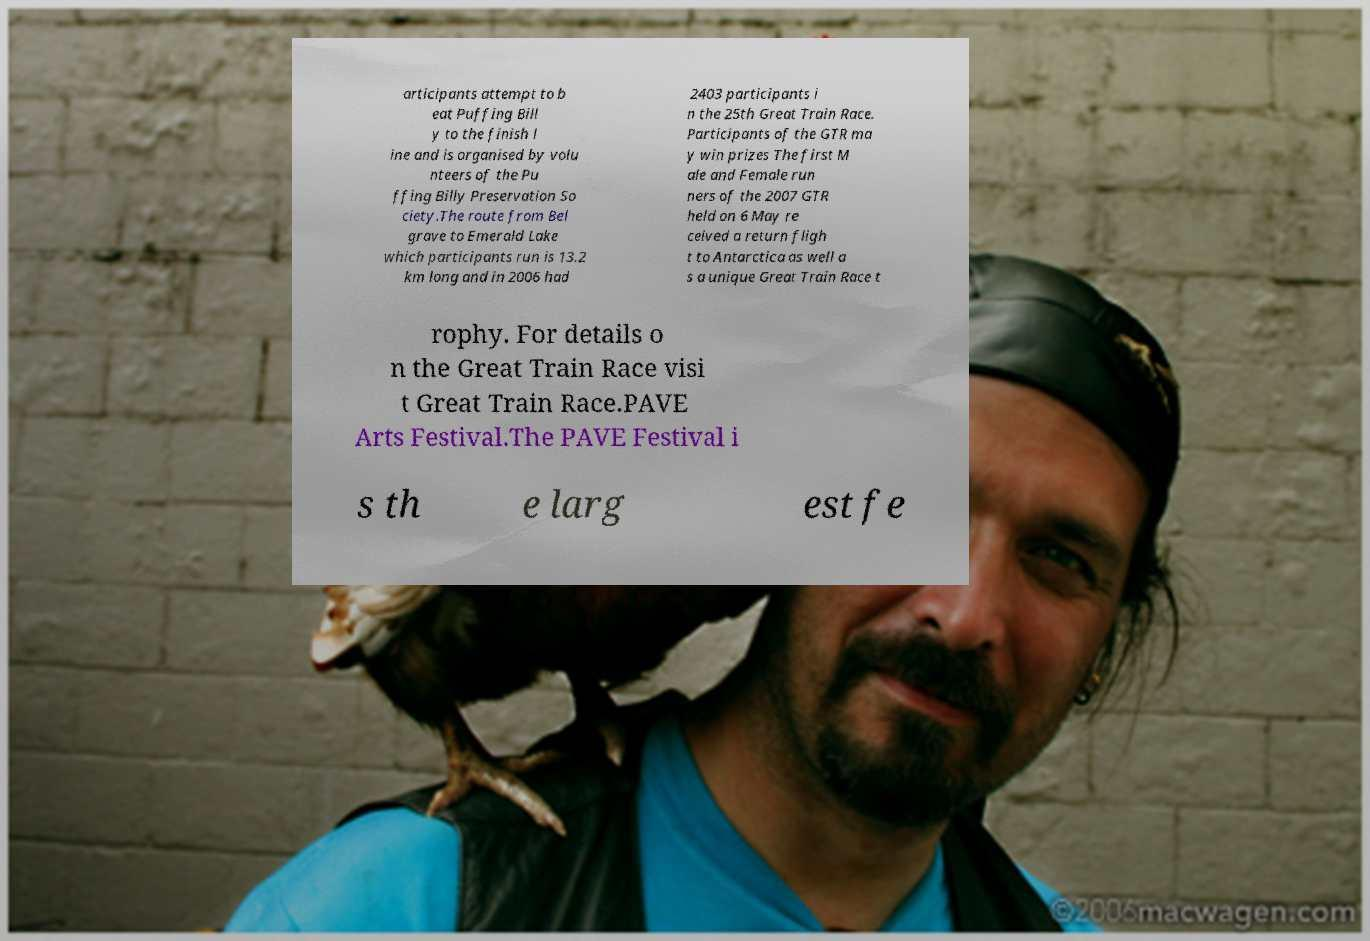Could you assist in decoding the text presented in this image and type it out clearly? articipants attempt to b eat Puffing Bill y to the finish l ine and is organised by volu nteers of the Pu ffing Billy Preservation So ciety.The route from Bel grave to Emerald Lake which participants run is 13.2 km long and in 2006 had 2403 participants i n the 25th Great Train Race. Participants of the GTR ma y win prizes The first M ale and Female run ners of the 2007 GTR held on 6 May re ceived a return fligh t to Antarctica as well a s a unique Great Train Race t rophy. For details o n the Great Train Race visi t Great Train Race.PAVE Arts Festival.The PAVE Festival i s th e larg est fe 